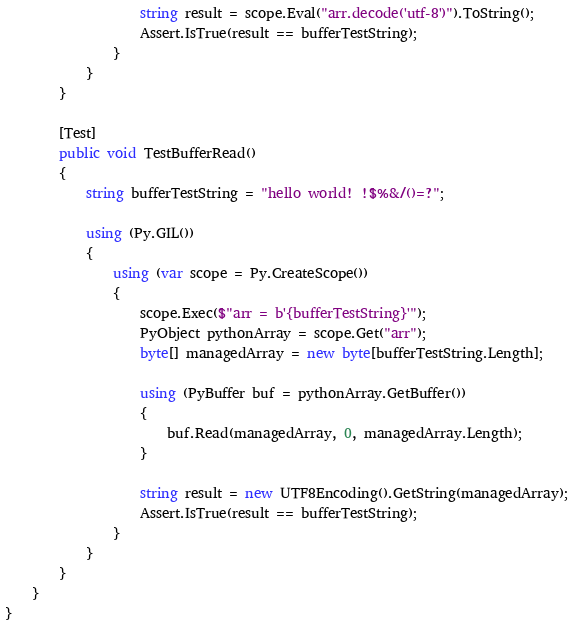<code> <loc_0><loc_0><loc_500><loc_500><_C#_>                    string result = scope.Eval("arr.decode('utf-8')").ToString();
                    Assert.IsTrue(result == bufferTestString);
                }
            }
        }

        [Test]
        public void TestBufferRead()
        {
            string bufferTestString = "hello world! !$%&/()=?";

            using (Py.GIL())
            {
                using (var scope = Py.CreateScope())
                {
                    scope.Exec($"arr = b'{bufferTestString}'");
                    PyObject pythonArray = scope.Get("arr");
                    byte[] managedArray = new byte[bufferTestString.Length];

                    using (PyBuffer buf = pythonArray.GetBuffer())
                    {
                        buf.Read(managedArray, 0, managedArray.Length);
                    }

                    string result = new UTF8Encoding().GetString(managedArray);
                    Assert.IsTrue(result == bufferTestString);
                }
            }
        }
    }
}
</code> 